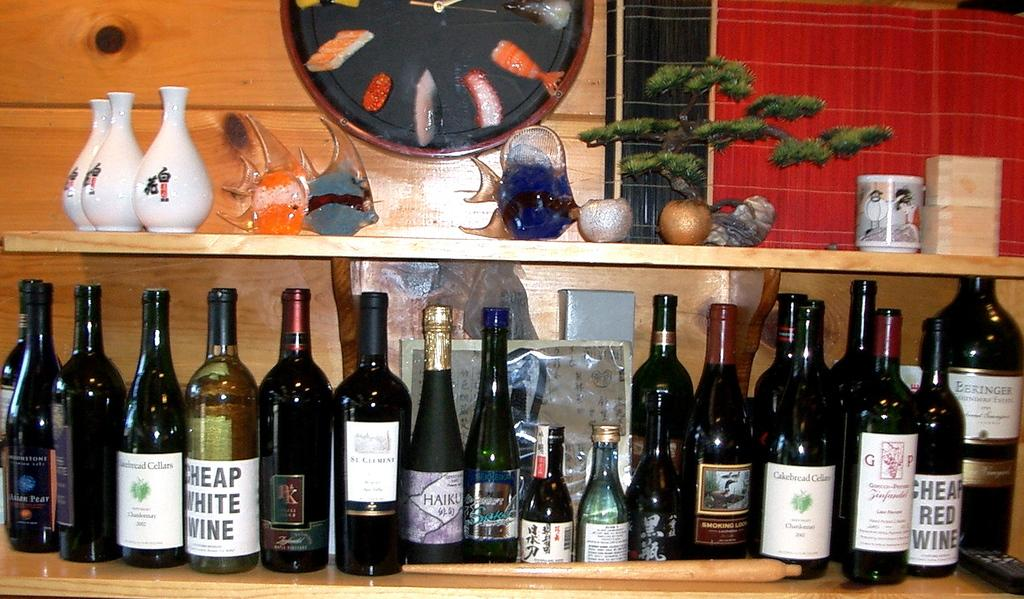<image>
Relay a brief, clear account of the picture shown. the words cheap white wine that is on a bottle 